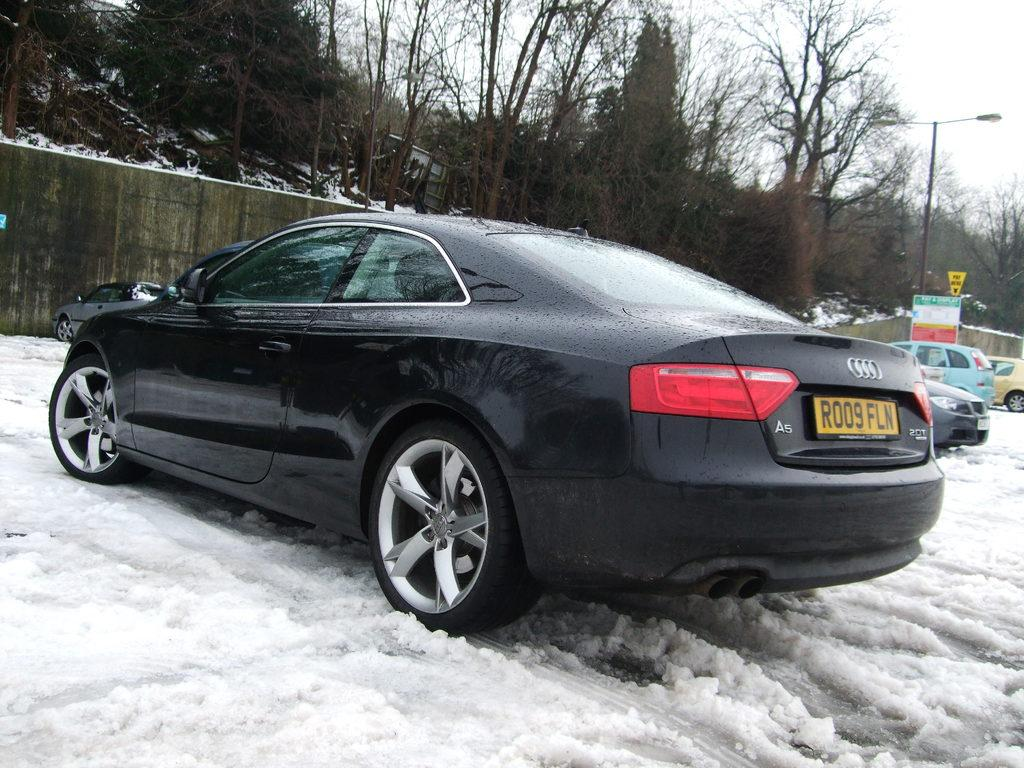What is the main subject of the image? The main subject of the image is cars on the snow. What can be seen in the background of the image? In the background of the image, there is a fence, trees, a pole, boards, and the sky. Can you describe the setting of the image? The image is set in a snowy environment with cars parked on the snow. There are various structures and natural elements visible in the background. What type of berry is growing on the edge of the fence in the image? There are no berries or edges of fences mentioned in the image; it only features cars on the snow and various background elements. 